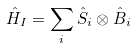<formula> <loc_0><loc_0><loc_500><loc_500>\hat { H } _ { I } = \sum _ { i } \hat { S } _ { i } \otimes \hat { B } _ { i }</formula> 